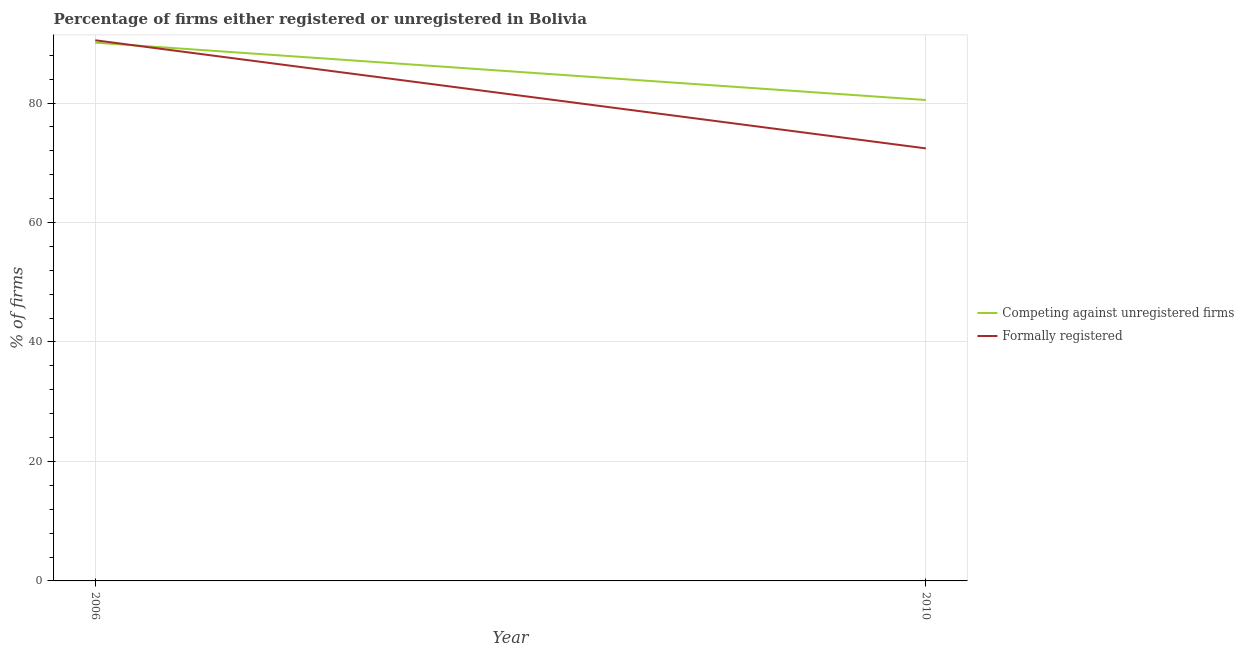How many different coloured lines are there?
Your answer should be very brief. 2. Does the line corresponding to percentage of registered firms intersect with the line corresponding to percentage of formally registered firms?
Your answer should be very brief. Yes. What is the percentage of formally registered firms in 2010?
Offer a terse response. 72.4. Across all years, what is the maximum percentage of formally registered firms?
Your answer should be very brief. 90.5. Across all years, what is the minimum percentage of formally registered firms?
Make the answer very short. 72.4. In which year was the percentage of formally registered firms maximum?
Give a very brief answer. 2006. In which year was the percentage of formally registered firms minimum?
Your answer should be very brief. 2010. What is the total percentage of formally registered firms in the graph?
Offer a terse response. 162.9. What is the difference between the percentage of registered firms in 2006 and that in 2010?
Provide a short and direct response. 9.6. What is the difference between the percentage of registered firms in 2006 and the percentage of formally registered firms in 2010?
Provide a short and direct response. 17.7. What is the average percentage of formally registered firms per year?
Provide a succinct answer. 81.45. In the year 2006, what is the difference between the percentage of formally registered firms and percentage of registered firms?
Provide a short and direct response. 0.4. In how many years, is the percentage of registered firms greater than 64 %?
Offer a terse response. 2. What is the ratio of the percentage of registered firms in 2006 to that in 2010?
Offer a very short reply. 1.12. Is the percentage of formally registered firms in 2006 less than that in 2010?
Offer a terse response. No. Does the percentage of formally registered firms monotonically increase over the years?
Make the answer very short. No. How many years are there in the graph?
Your response must be concise. 2. What is the difference between two consecutive major ticks on the Y-axis?
Make the answer very short. 20. Does the graph contain grids?
Give a very brief answer. Yes. How many legend labels are there?
Your answer should be very brief. 2. How are the legend labels stacked?
Ensure brevity in your answer.  Vertical. What is the title of the graph?
Offer a terse response. Percentage of firms either registered or unregistered in Bolivia. Does "Urban" appear as one of the legend labels in the graph?
Make the answer very short. No. What is the label or title of the Y-axis?
Ensure brevity in your answer.  % of firms. What is the % of firms of Competing against unregistered firms in 2006?
Your answer should be very brief. 90.1. What is the % of firms in Formally registered in 2006?
Offer a terse response. 90.5. What is the % of firms in Competing against unregistered firms in 2010?
Offer a terse response. 80.5. What is the % of firms in Formally registered in 2010?
Offer a terse response. 72.4. Across all years, what is the maximum % of firms of Competing against unregistered firms?
Offer a terse response. 90.1. Across all years, what is the maximum % of firms in Formally registered?
Ensure brevity in your answer.  90.5. Across all years, what is the minimum % of firms in Competing against unregistered firms?
Provide a succinct answer. 80.5. Across all years, what is the minimum % of firms in Formally registered?
Give a very brief answer. 72.4. What is the total % of firms in Competing against unregistered firms in the graph?
Offer a very short reply. 170.6. What is the total % of firms in Formally registered in the graph?
Your answer should be compact. 162.9. What is the difference between the % of firms of Competing against unregistered firms in 2006 and that in 2010?
Provide a short and direct response. 9.6. What is the average % of firms in Competing against unregistered firms per year?
Offer a very short reply. 85.3. What is the average % of firms of Formally registered per year?
Offer a very short reply. 81.45. What is the ratio of the % of firms in Competing against unregistered firms in 2006 to that in 2010?
Make the answer very short. 1.12. What is the difference between the highest and the second highest % of firms of Competing against unregistered firms?
Give a very brief answer. 9.6. What is the difference between the highest and the lowest % of firms in Competing against unregistered firms?
Make the answer very short. 9.6. 